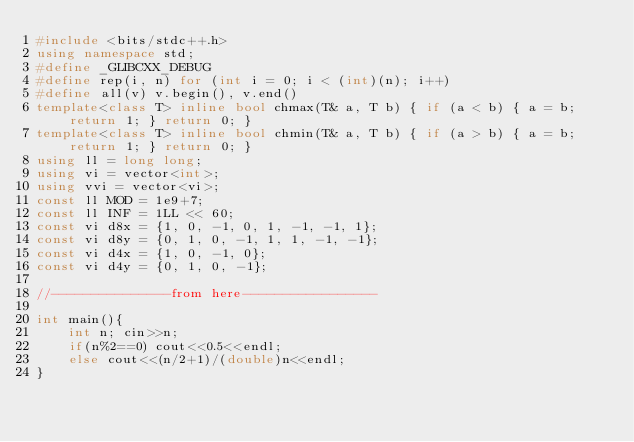Convert code to text. <code><loc_0><loc_0><loc_500><loc_500><_C++_>#include <bits/stdc++.h>
using namespace std;
#define _GLIBCXX_DEBUG
#define rep(i, n) for (int i = 0; i < (int)(n); i++)
#define all(v) v.begin(), v.end()
template<class T> inline bool chmax(T& a, T b) { if (a < b) { a = b; return 1; } return 0; }
template<class T> inline bool chmin(T& a, T b) { if (a > b) { a = b; return 1; } return 0; }
using ll = long long;
using vi = vector<int>;
using vvi = vector<vi>;
const ll MOD = 1e9+7;
const ll INF = 1LL << 60;
const vi d8x = {1, 0, -1, 0, 1, -1, -1, 1};
const vi d8y = {0, 1, 0, -1, 1, 1, -1, -1};
const vi d4x = {1, 0, -1, 0};
const vi d4y = {0, 1, 0, -1};

//---------------from here-----------------

int main(){
    int n; cin>>n;
    if(n%2==0) cout<<0.5<<endl;
    else cout<<(n/2+1)/(double)n<<endl;
}</code> 